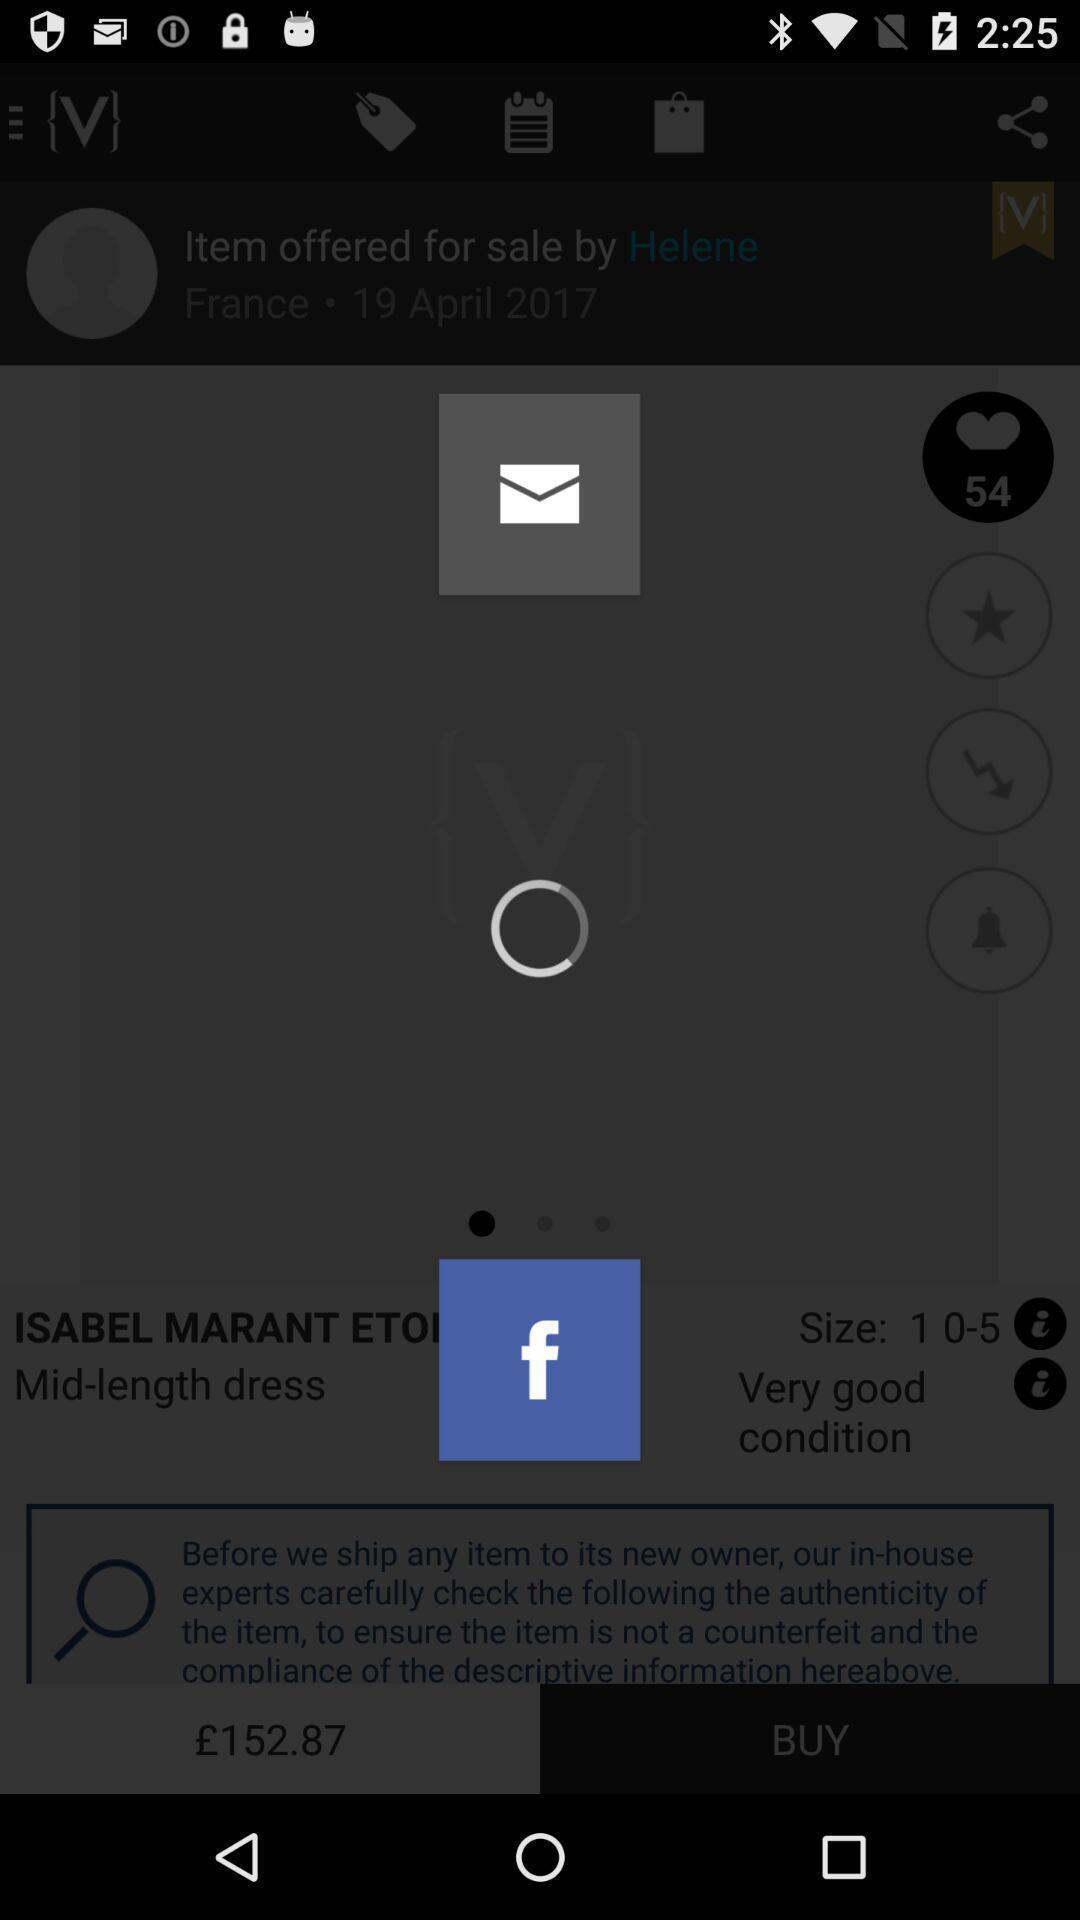What can you discern from this picture? Screen showing loading page. 